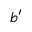<formula> <loc_0><loc_0><loc_500><loc_500>b ^ { \prime }</formula> 